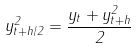<formula> <loc_0><loc_0><loc_500><loc_500>y _ { t + h / 2 } ^ { 2 } = \frac { y _ { t } + y _ { t + h } ^ { 2 } } { 2 }</formula> 